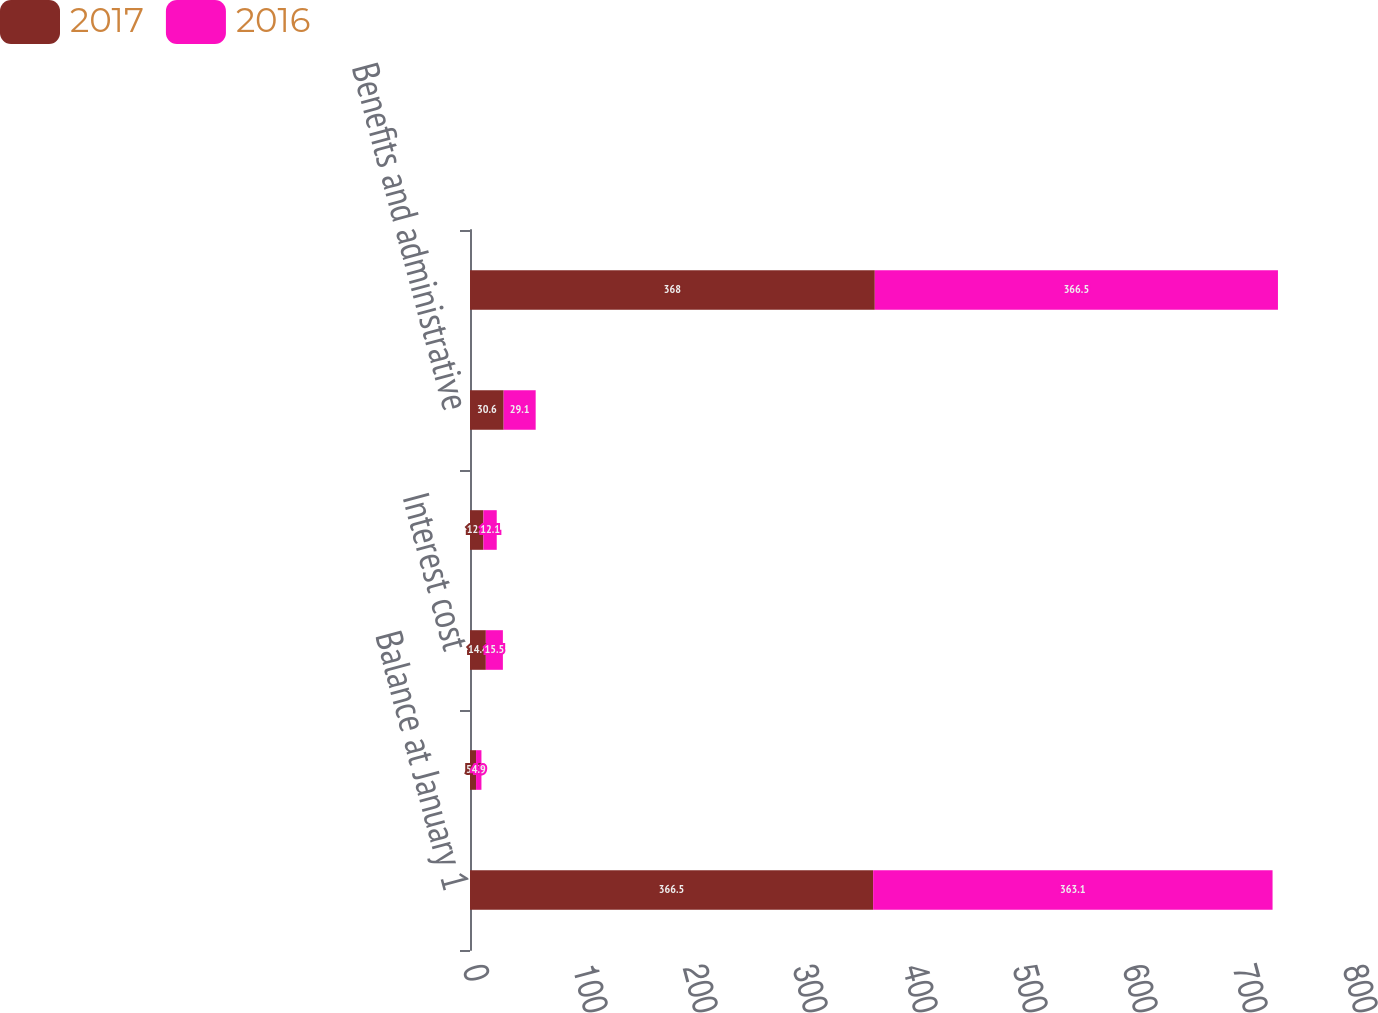<chart> <loc_0><loc_0><loc_500><loc_500><stacked_bar_chart><ecel><fcel>Balance at January 1<fcel>Service cost<fcel>Interest cost<fcel>Actuarial loss<fcel>Benefits and administrative<fcel>Balance at December 31<nl><fcel>2017<fcel>366.5<fcel>5.5<fcel>14.4<fcel>12.2<fcel>30.6<fcel>368<nl><fcel>2016<fcel>363.1<fcel>4.9<fcel>15.5<fcel>12.1<fcel>29.1<fcel>366.5<nl></chart> 